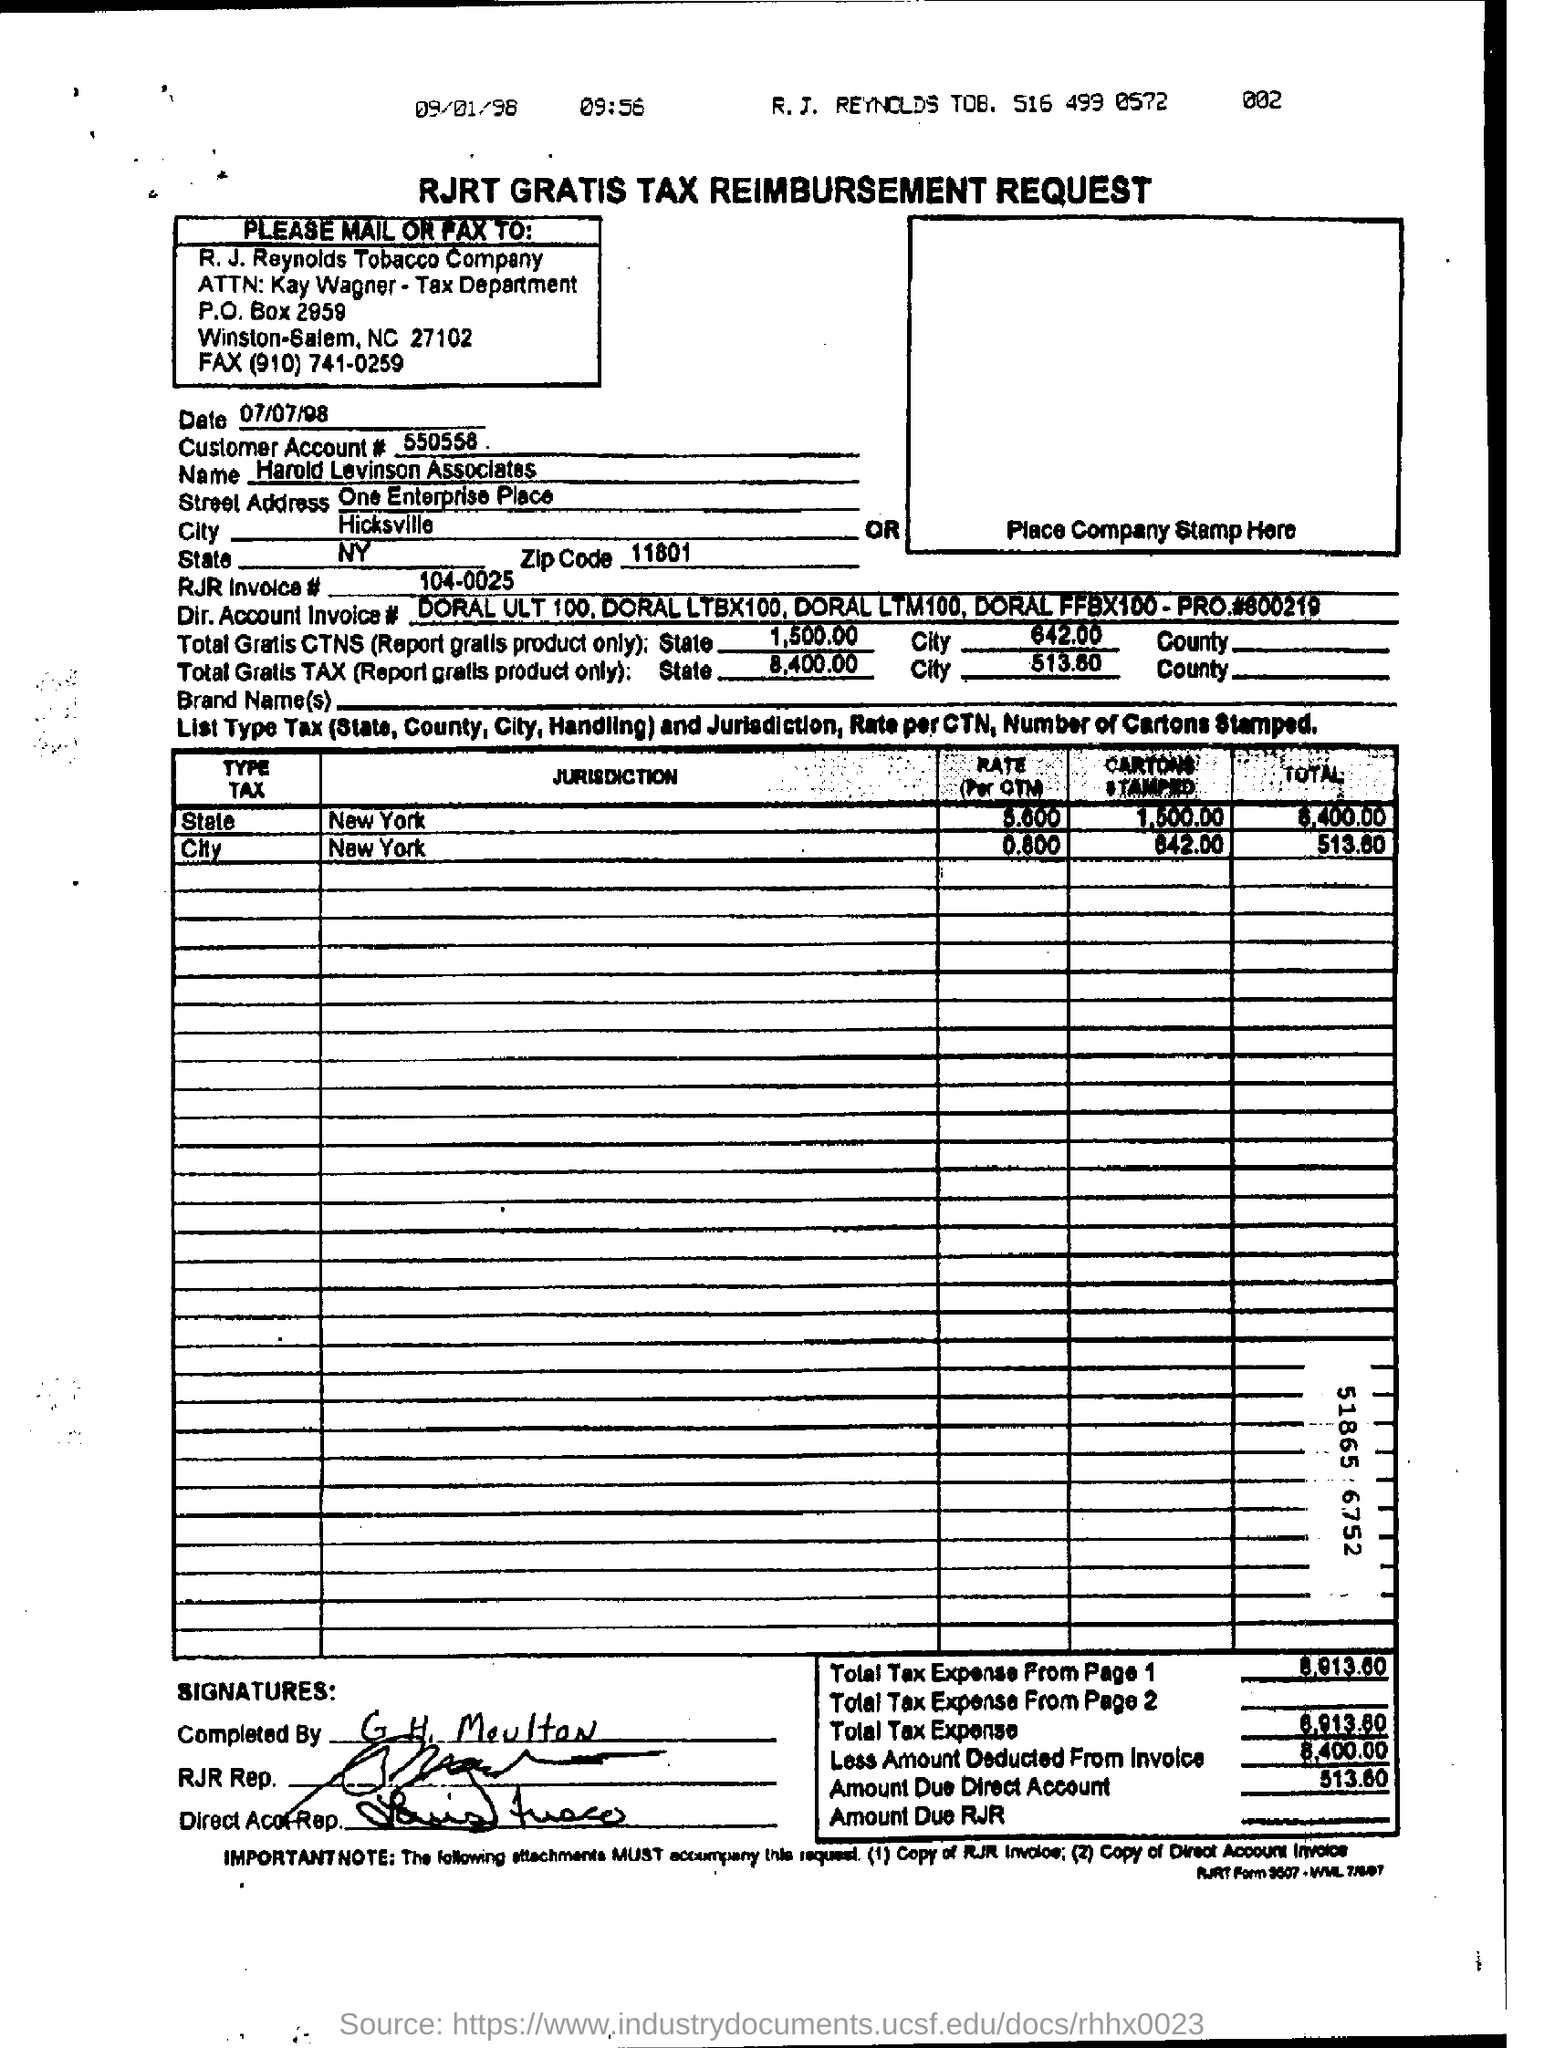Give some essential details in this illustration. Harold Levinson Associates has a street address of One Enterprise Place. The amount due to the direct account is 513.60. 